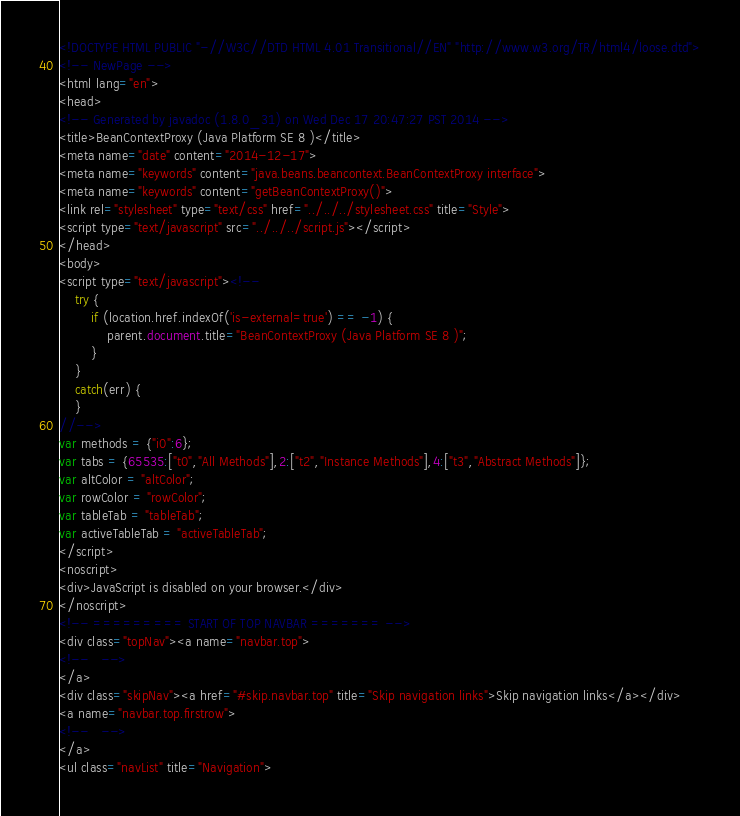<code> <loc_0><loc_0><loc_500><loc_500><_HTML_><!DOCTYPE HTML PUBLIC "-//W3C//DTD HTML 4.01 Transitional//EN" "http://www.w3.org/TR/html4/loose.dtd">
<!-- NewPage -->
<html lang="en">
<head>
<!-- Generated by javadoc (1.8.0_31) on Wed Dec 17 20:47:27 PST 2014 -->
<title>BeanContextProxy (Java Platform SE 8 )</title>
<meta name="date" content="2014-12-17">
<meta name="keywords" content="java.beans.beancontext.BeanContextProxy interface">
<meta name="keywords" content="getBeanContextProxy()">
<link rel="stylesheet" type="text/css" href="../../../stylesheet.css" title="Style">
<script type="text/javascript" src="../../../script.js"></script>
</head>
<body>
<script type="text/javascript"><!--
    try {
        if (location.href.indexOf('is-external=true') == -1) {
            parent.document.title="BeanContextProxy (Java Platform SE 8 )";
        }
    }
    catch(err) {
    }
//-->
var methods = {"i0":6};
var tabs = {65535:["t0","All Methods"],2:["t2","Instance Methods"],4:["t3","Abstract Methods"]};
var altColor = "altColor";
var rowColor = "rowColor";
var tableTab = "tableTab";
var activeTableTab = "activeTableTab";
</script>
<noscript>
<div>JavaScript is disabled on your browser.</div>
</noscript>
<!-- ========= START OF TOP NAVBAR ======= -->
<div class="topNav"><a name="navbar.top">
<!--   -->
</a>
<div class="skipNav"><a href="#skip.navbar.top" title="Skip navigation links">Skip navigation links</a></div>
<a name="navbar.top.firstrow">
<!--   -->
</a>
<ul class="navList" title="Navigation"></code> 